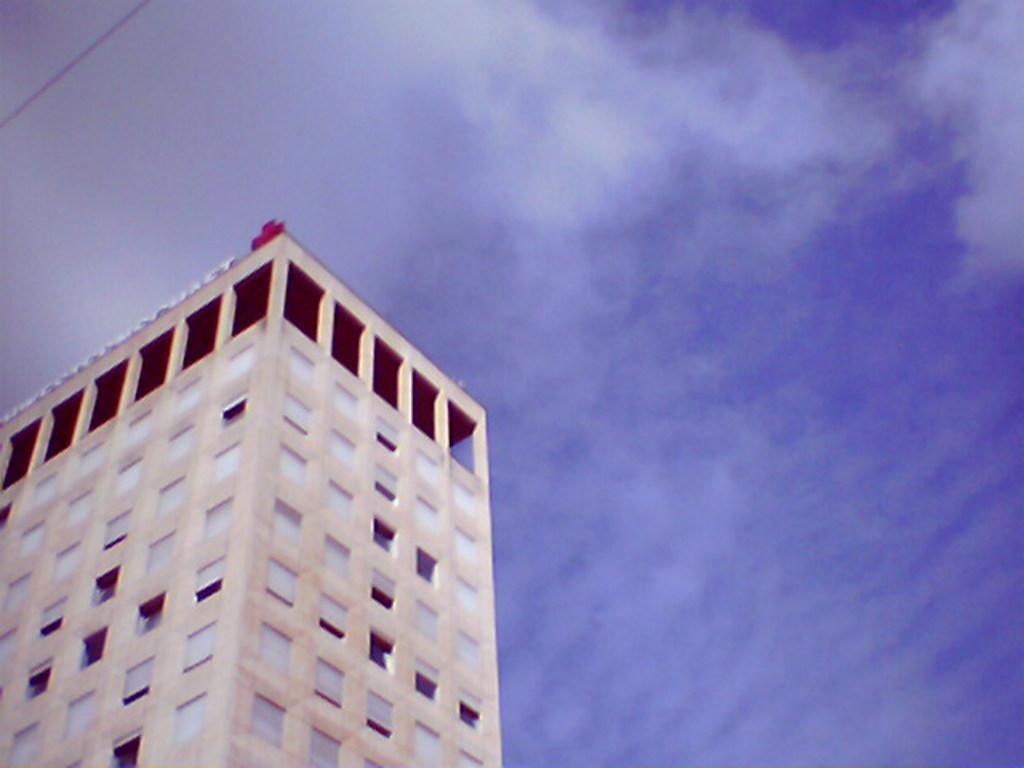How would you summarize this image in a sentence or two? In this picture I see a building in front and on the top left of this image I see a black color thing and in the background I see the sky. 